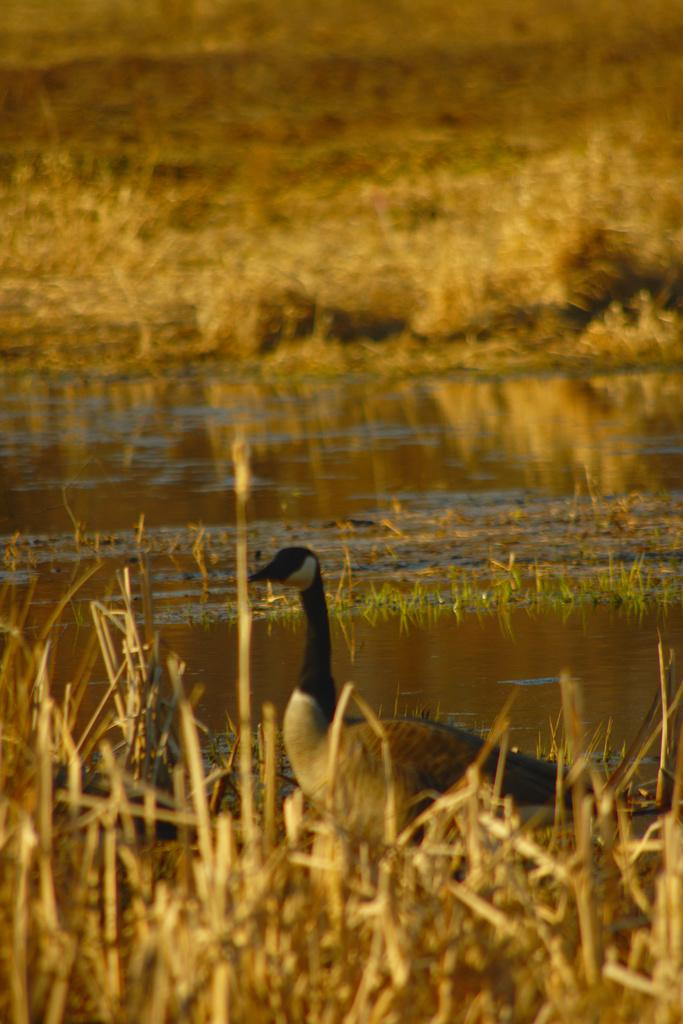What type of animal is in the picture? There is a duck in the picture. Can you describe the duck's appearance? The duck has a long neck. What is visible behind the duck? There is water visible behind the duck. What type of vegetation is present in the picture? There is dry grass in the picture. What type of breakfast is the duck preparing in the picture? There is no indication in the image that the duck is preparing breakfast, as ducks do not typically engage in such activities. 